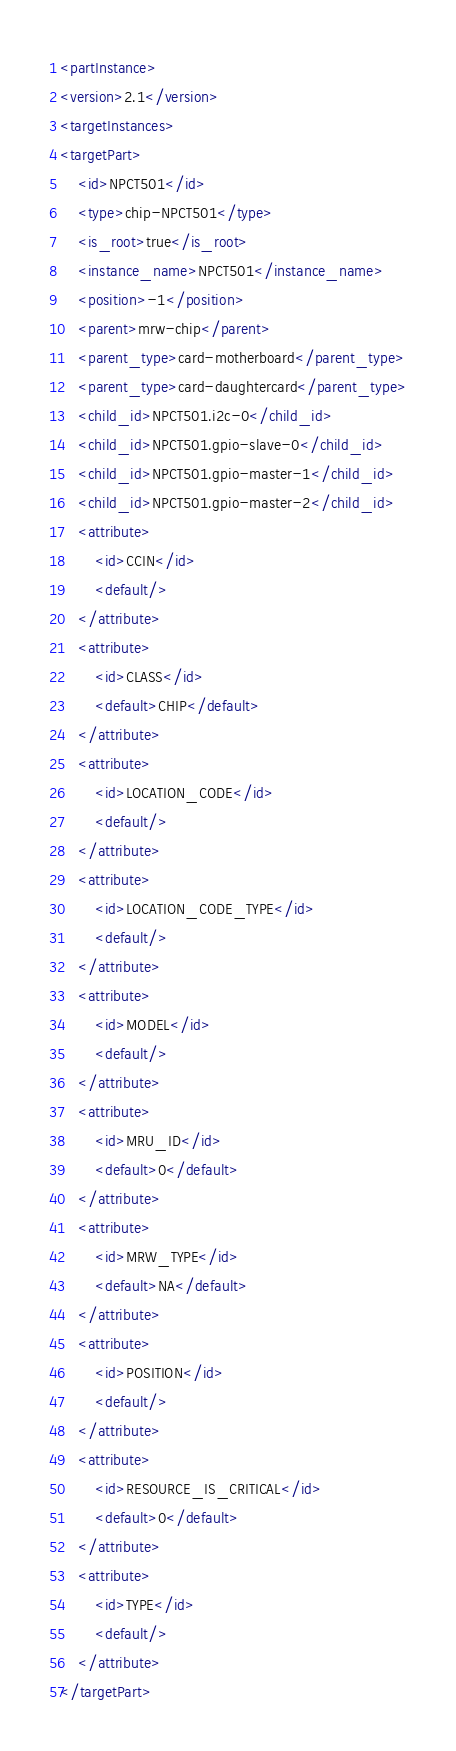<code> <loc_0><loc_0><loc_500><loc_500><_XML_><partInstance>
<version>2.1</version>
<targetInstances>
<targetPart>
	<id>NPCT501</id>
	<type>chip-NPCT501</type>
	<is_root>true</is_root>
	<instance_name>NPCT501</instance_name>
	<position>-1</position>
	<parent>mrw-chip</parent>
	<parent_type>card-motherboard</parent_type>
	<parent_type>card-daughtercard</parent_type>
	<child_id>NPCT501.i2c-0</child_id>
	<child_id>NPCT501.gpio-slave-0</child_id>
	<child_id>NPCT501.gpio-master-1</child_id>
	<child_id>NPCT501.gpio-master-2</child_id>
	<attribute>
		<id>CCIN</id>
		<default/>
	</attribute>
	<attribute>
		<id>CLASS</id>
		<default>CHIP</default>
	</attribute>
	<attribute>
		<id>LOCATION_CODE</id>
		<default/>
	</attribute>
	<attribute>
		<id>LOCATION_CODE_TYPE</id>
		<default/>
	</attribute>
	<attribute>
		<id>MODEL</id>
		<default/>
	</attribute>
	<attribute>
		<id>MRU_ID</id>
		<default>0</default>
	</attribute>
	<attribute>
		<id>MRW_TYPE</id>
		<default>NA</default>
	</attribute>
	<attribute>
		<id>POSITION</id>
		<default/>
	</attribute>
	<attribute>
		<id>RESOURCE_IS_CRITICAL</id>
		<default>0</default>
	</attribute>
	<attribute>
		<id>TYPE</id>
		<default/>
	</attribute>
</targetPart></code> 